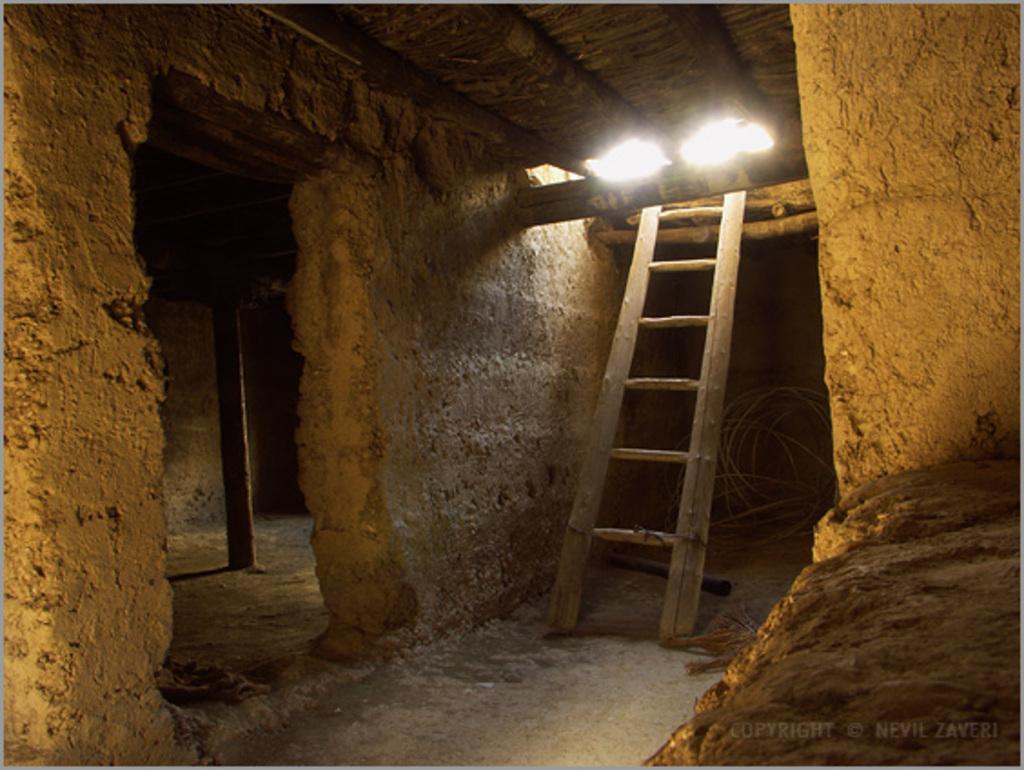Please provide a concise description of this image. In this image we can see an inner view of a building containing a ladder, a wooden pole and some wires on the ground. 